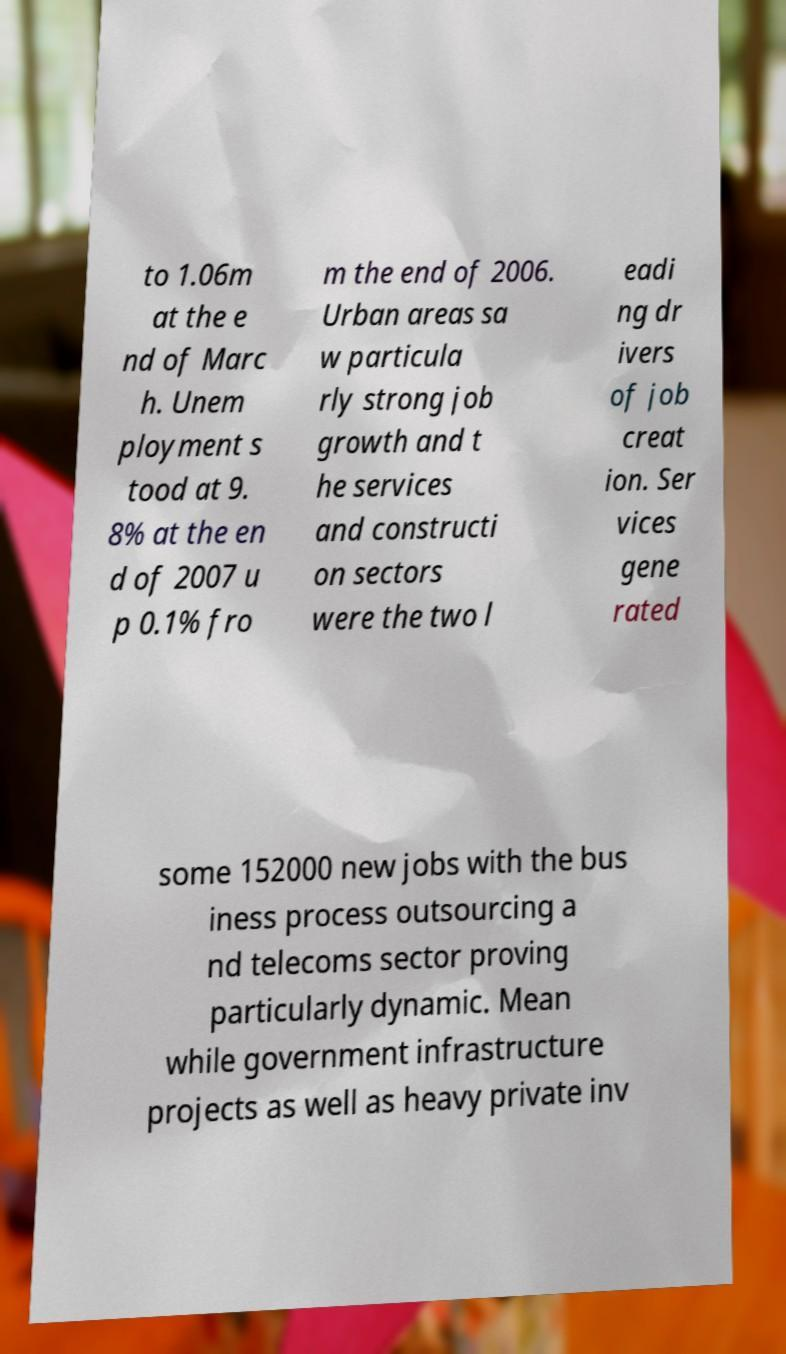Can you read and provide the text displayed in the image?This photo seems to have some interesting text. Can you extract and type it out for me? to 1.06m at the e nd of Marc h. Unem ployment s tood at 9. 8% at the en d of 2007 u p 0.1% fro m the end of 2006. Urban areas sa w particula rly strong job growth and t he services and constructi on sectors were the two l eadi ng dr ivers of job creat ion. Ser vices gene rated some 152000 new jobs with the bus iness process outsourcing a nd telecoms sector proving particularly dynamic. Mean while government infrastructure projects as well as heavy private inv 